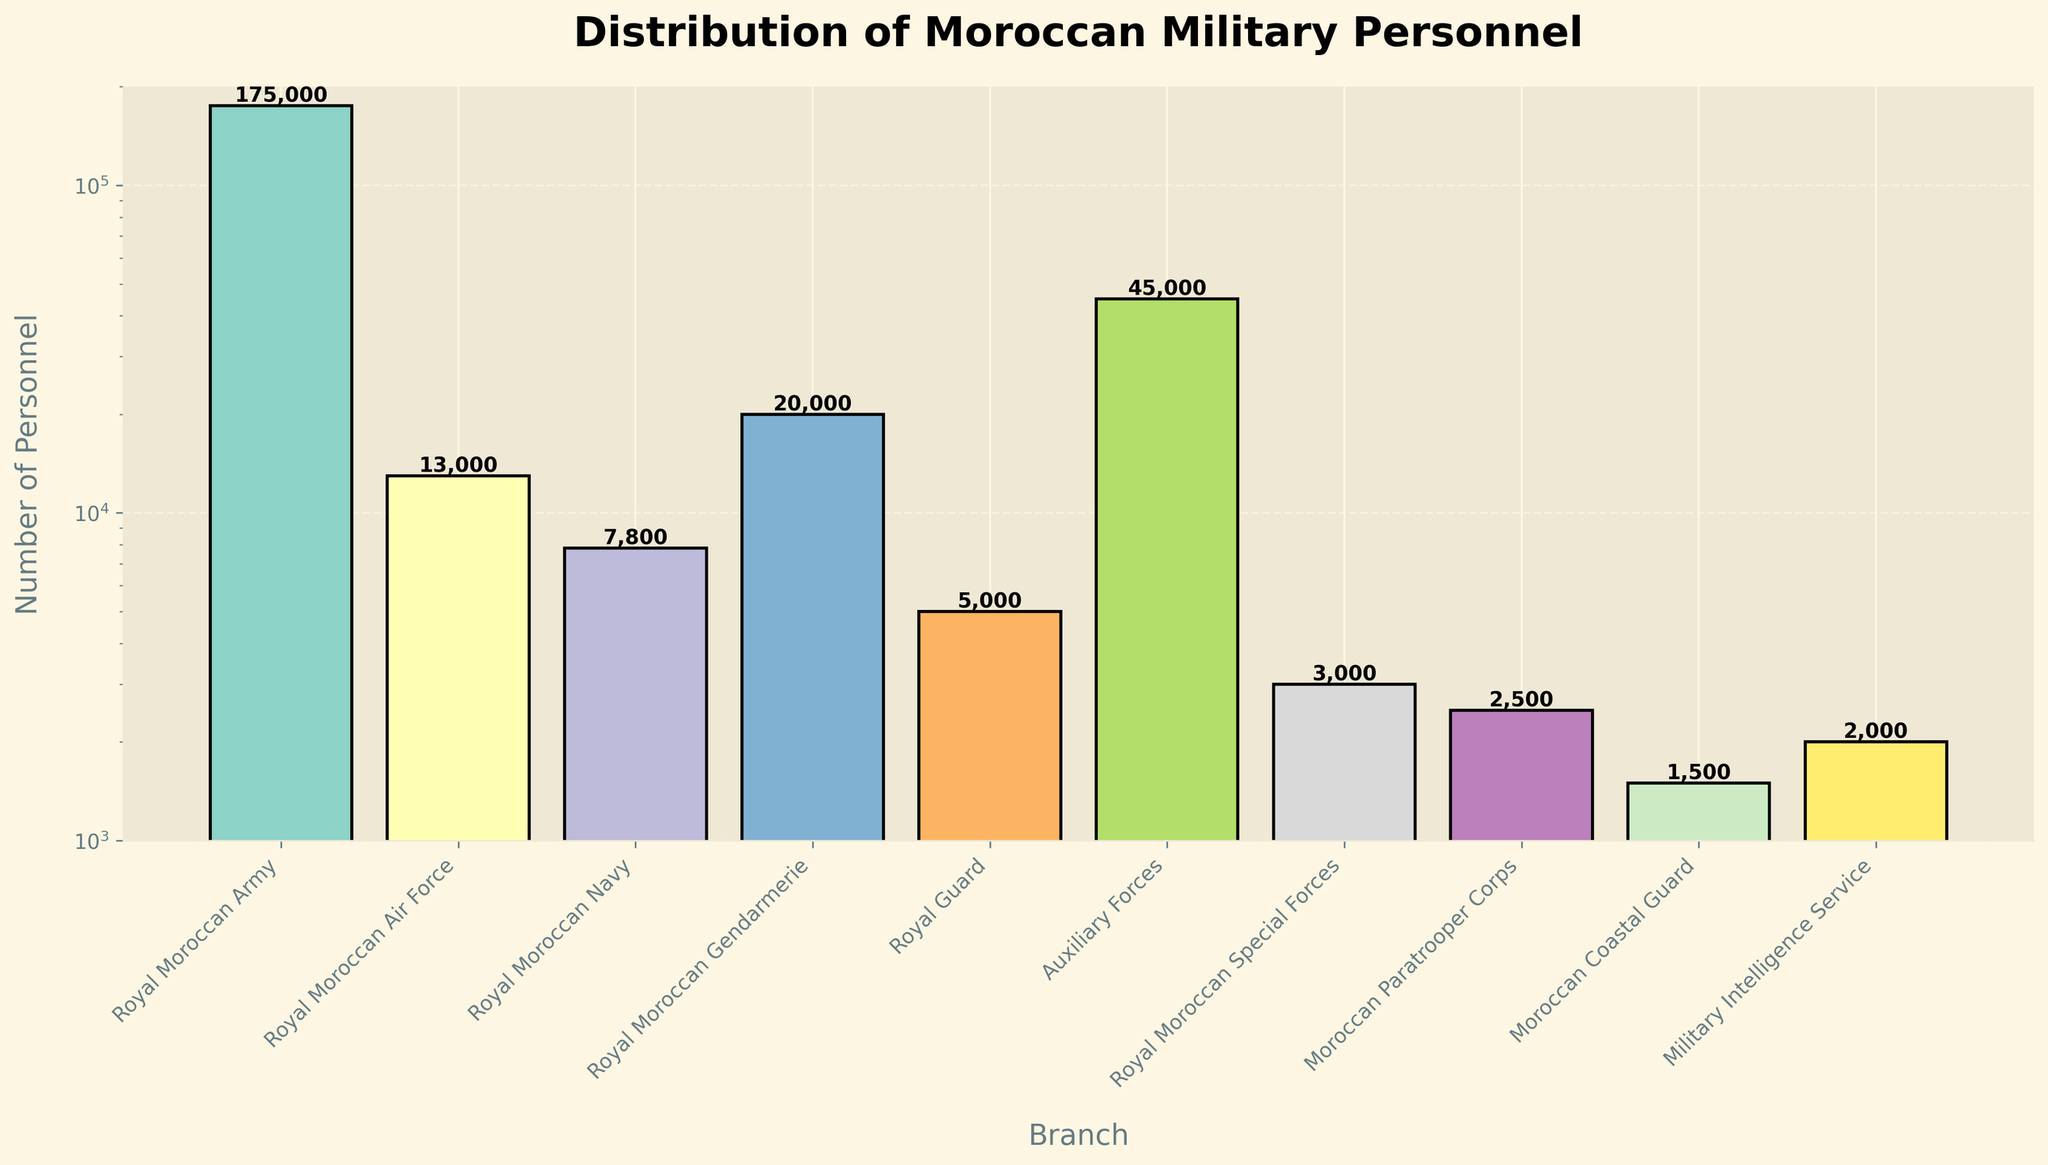Which branch has the highest number of personnel? From the bar chart, the tallest bar represents the Royal Moroccan Army. The height of the bar indicates the number of personnel.
Answer: Royal Moroccan Army Which branch has the fewest number of personnel? By looking at the heights of the bars, the shortest bar belongs to the Moroccan Coastal Guard, indicating it has the fewest personnel.
Answer: Moroccan Coastal Guard What is the total number of personnel in the Royal Moroccan Navy and the Royal Moroccan Special Forces combined? The personnel in the Royal Moroccan Navy is 7,800, and in the Royal Moroccan Special Forces, it is 3,000. Summing these two numbers: 7,800 + 3,000 = 10,800.
Answer: 10,800 How does the number of personnel in the Auxiliary Forces compare to the Royal Moroccan Air Force? The bar for the Auxiliary Forces is taller than the one for the Royal Moroccan Air Force. The exact numbers are 45,000 for the Auxiliary Forces and 13,000 for the Royal Moroccan Air Force. Thus, Auxiliary Forces have more personnel.
Answer: Auxiliary Forces have more personnel By how much does the number of personnel in the Royal Moroccan Army exceed the total personnel in the Royal Guard and Moroccan Paratrooper Corps? The Royal Moroccan Army has 175,000 personnel. The Royal Guard has 5,000, and the Moroccan Paratrooper Corps has 2,500; their combined total is 5,000 + 2,500 = 7,500. The difference is 175,000 - 7,500 = 167,500.
Answer: 167,500 Which branches have personnel counts between 1,000 and 10,000? By looking at the bars between 1,000 and 10,000 personnel: Royal Moroccan Navy (7,800), Royal Guard (5,000), Royal Moroccan Special Forces (3,000), and Moroccan Paratrooper Corps (2,500) fall within this range.
Answer: Royal Moroccan Navy, Royal Guard, Royal Moroccan Special Forces, Moroccan Paratrooper Corps What is the ratio of personnel in the Royal Moroccan Army to those in the Military Intelligence Service? The Royal Moroccan Army has 175,000 personnel and the Military Intelligence Service has 2,000. The ratio is calculated as 175,000 / 2,000 = 87.5.
Answer: 87.5 How do the heights of the bars for the Royal Moroccan Air Force and the Royal Moroccan Gendarmerie compare? The bar for the Royal Moroccan Gendarmerie is taller than that for the Royal Moroccan Air Force. This means the Royal Moroccan Gendarmerie has more personnel (20,000) compared to the Royal Moroccan Air Force (13,000).
Answer: Royal Moroccan Gendarmerie's bar is taller What is the median number of personnel across all branches shown? To find the median, list all personnel counts in ascending order: 1,500 (Moroccan Coastal Guard), 2,000 (Military Intelligence Service), 2,500 (Moroccan Paratrooper Corps), 3,000 (Royal Moroccan Special Forces), 5,000 (Royal Guard), 7,800 (Royal Moroccan Navy), 13,000 (Royal Moroccan Air Force), 20,000 (Royal Moroccan Gendarmerie), 45,000 (Auxiliary Forces), 175,000 (Royal Moroccan Army). The middle values are 5,000 and 7,800. Their average is (5,000 + 7,800) / 2 = 6,400.
Answer: 6,400 